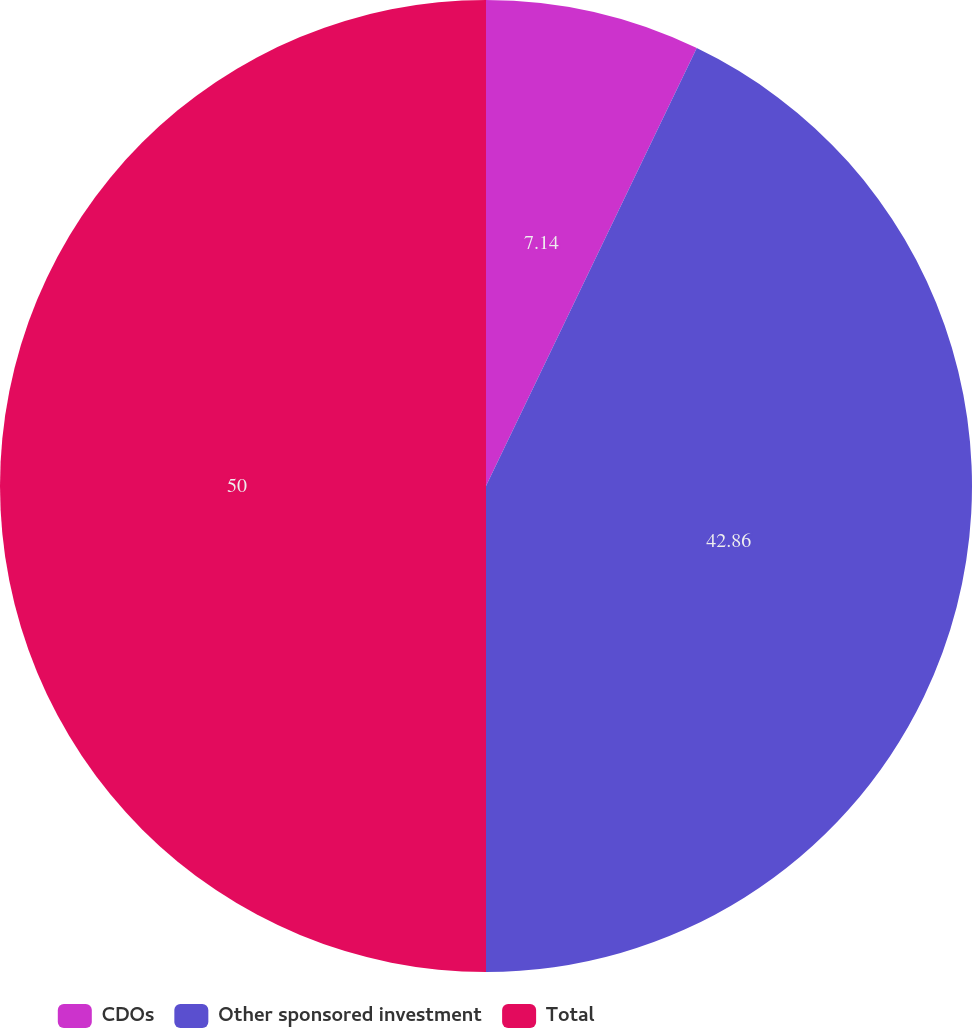Convert chart. <chart><loc_0><loc_0><loc_500><loc_500><pie_chart><fcel>CDOs<fcel>Other sponsored investment<fcel>Total<nl><fcel>7.14%<fcel>42.86%<fcel>50.0%<nl></chart> 